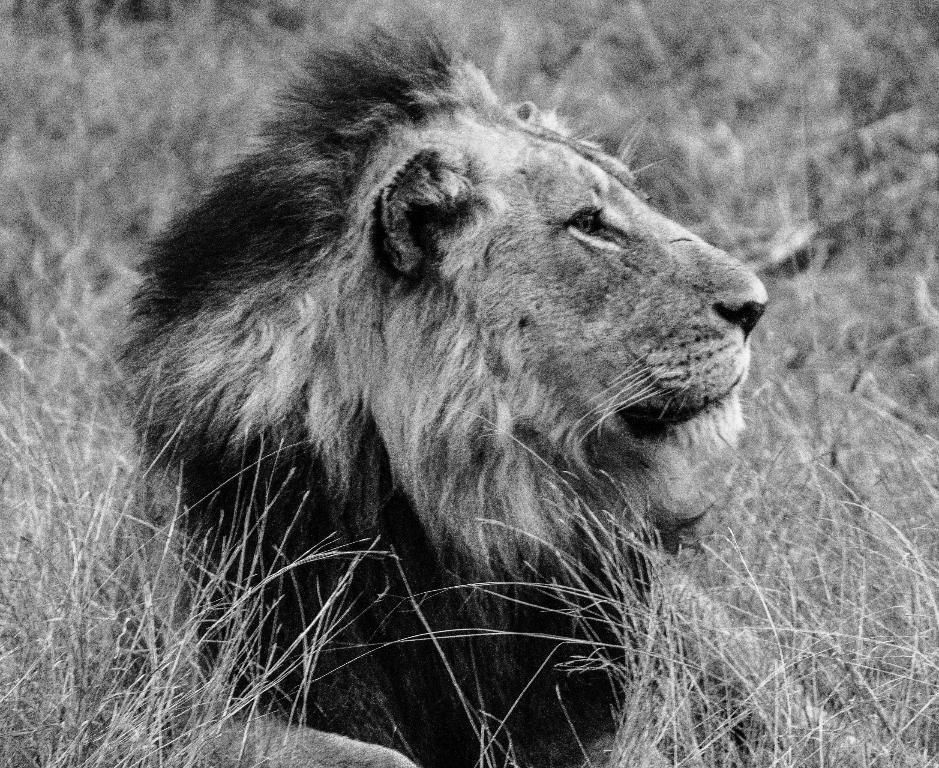What is the color scheme of the image? The image is black and white. What animal is featured in the image? There is a lion in the image. What can be seen in the background of the image? There are plants in the background of the image. Can you see any trails made by the lion in the image? There are no trails visible in the image, as it is a still image of a lion. What type of bushes can be seen in the image? There is no mention of bushes in the provided facts, and the image only shows a lion and plants in the background. 